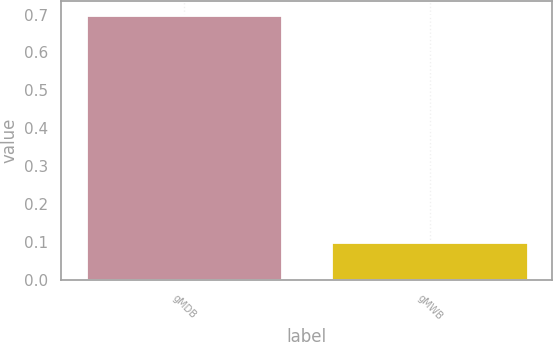<chart> <loc_0><loc_0><loc_500><loc_500><bar_chart><fcel>gMDB<fcel>gMWB<nl><fcel>0.7<fcel>0.1<nl></chart> 